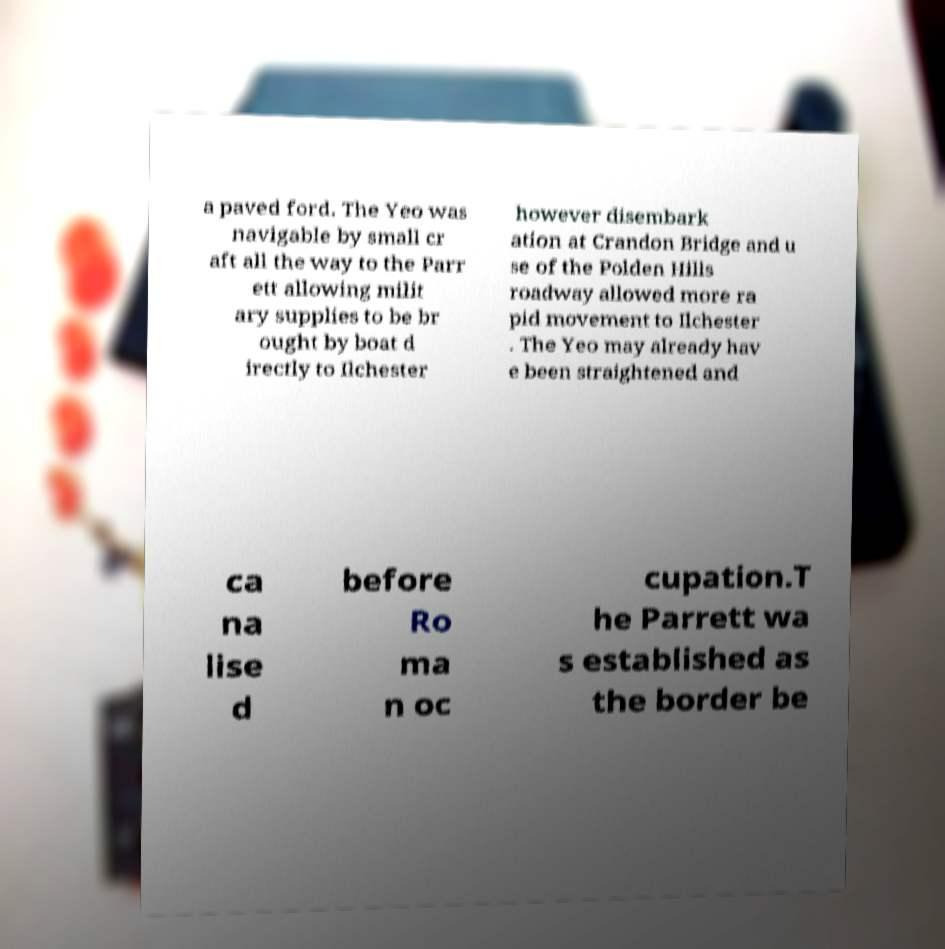Can you read and provide the text displayed in the image?This photo seems to have some interesting text. Can you extract and type it out for me? a paved ford. The Yeo was navigable by small cr aft all the way to the Parr ett allowing milit ary supplies to be br ought by boat d irectly to Ilchester however disembark ation at Crandon Bridge and u se of the Polden Hills roadway allowed more ra pid movement to Ilchester . The Yeo may already hav e been straightened and ca na lise d before Ro ma n oc cupation.T he Parrett wa s established as the border be 